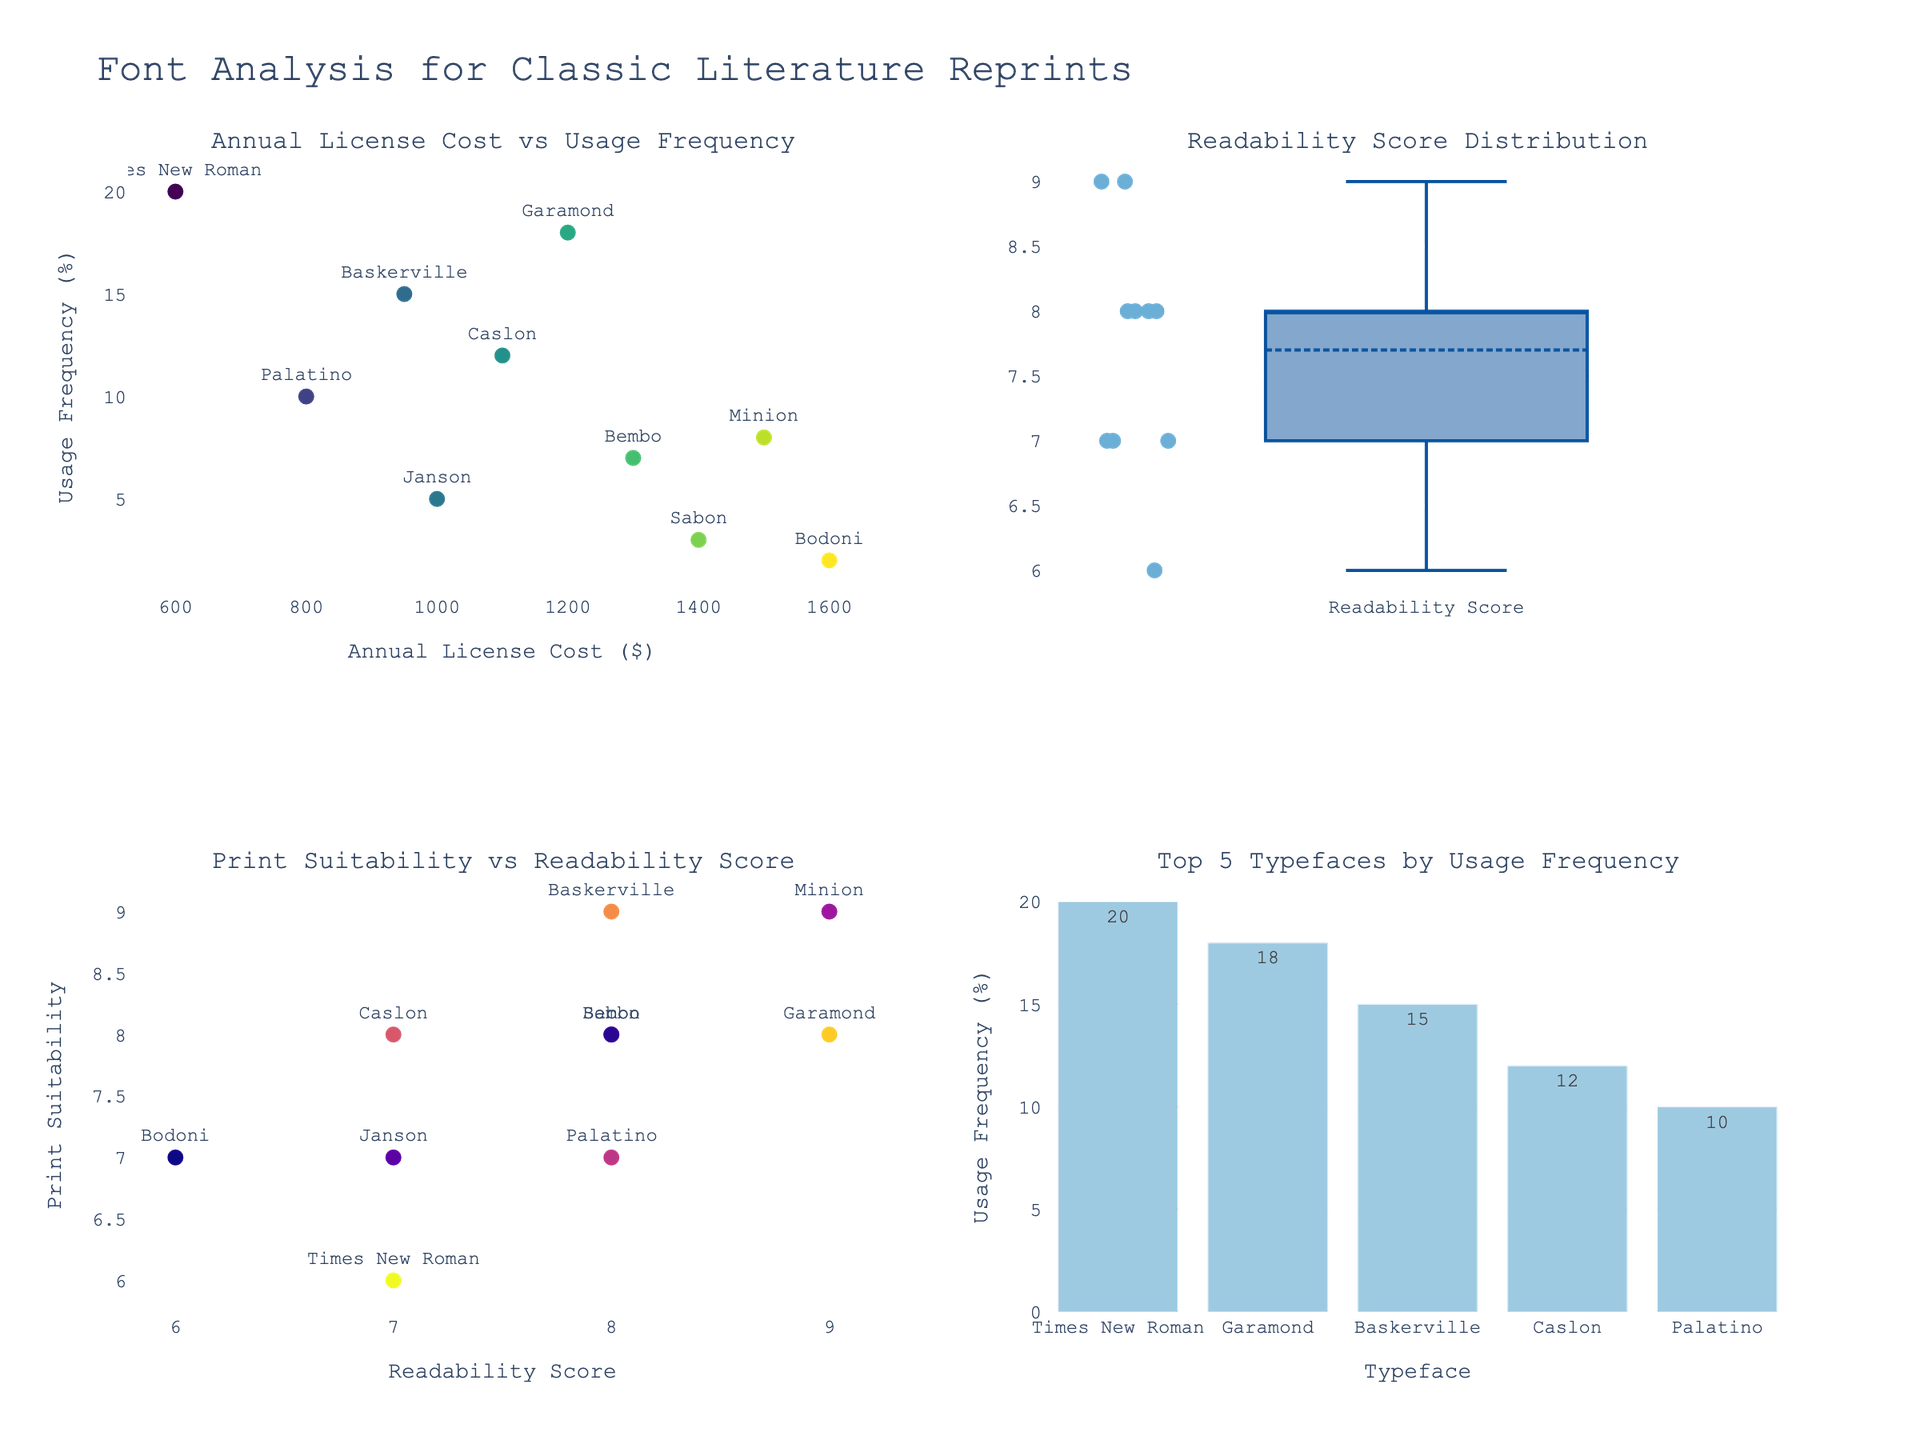what is the title of the figure? The title is usually at the top of the figure. The title text for the figure is "Font Analysis for Classic Literature Reprints".
Answer: Font Analysis for Classic Literature Reprints how many subplot titles are there? Each subplot has a title, and the figure has four subplots. Therefore, there are four subplot titles.
Answer: 4 which typeface has the highest annual license cost? To determine this, look at the scatter plot in the top-left and identify the data point that is farthest to the right. The farthest right data point corresponds to Bodoni with an annual cost of $1600.
Answer: Bodoni what's the average readability score of the typefaces? To find the average readability score, locate the box plot in the top-right which represents the Readability Score Distribution. The readytability scores are (9, 8, 7, 8, 7, 9, 8, 7, 8, 6). Sum these up: 9+8+7+8+7+9+8+7+8+6 = 77. Then, divide by the number of typefaces (10). The average is 77/10.
Answer: 7.7 which typeface has the highest usage frequency? The top 5 bar chart in the bottom-right shows usage frequencies. The highest bar corresponds to Times New Roman with 20%.
Answer: Times New Roman how does readability score correlate with print suitability? Look at the scatter plot in the bottom-left, where Readability Score is on the x-axis and Print Suitability is on the y-axis. The points form a roughly ascending diagonal line, indicating a positive correlation.
Answer: Positively correlated which typeface is the most frequently used among the top 5? Among the top 5 typefaces by usage frequency, identified in the bottom-right bar chart, the one with the highest frequency is Times New Roman with 20%.
Answer: Times New Roman what's the median print suitability score? In the scatter plot in the bottom-left corner, locate the Print Suitability scores: (8, 9, 8, 7, 6, 9, 8, 7, 8, 7). Sort these scores: (6, 7, 7, 7, 7, 8, 8, 8, 8, 9, 9). The median, the middle value, is the 5th and 6th values averaged together: (7+8)/2 = 7.5.
Answer: 7.5 which typeface has both high readability and high print suitability? In the scatter plot in the bottom-left, look for typefaces that are toward the top-right. Minion (9, 9) has the highest readability and print suitability scores.
Answer: Minion which typeface has the lowest usage frequency? In the bar chart in the bottom-right, identify the typeface with the shortest bar. Bodoni has the lowest usage frequency at 2%.
Answer: Bodoni 